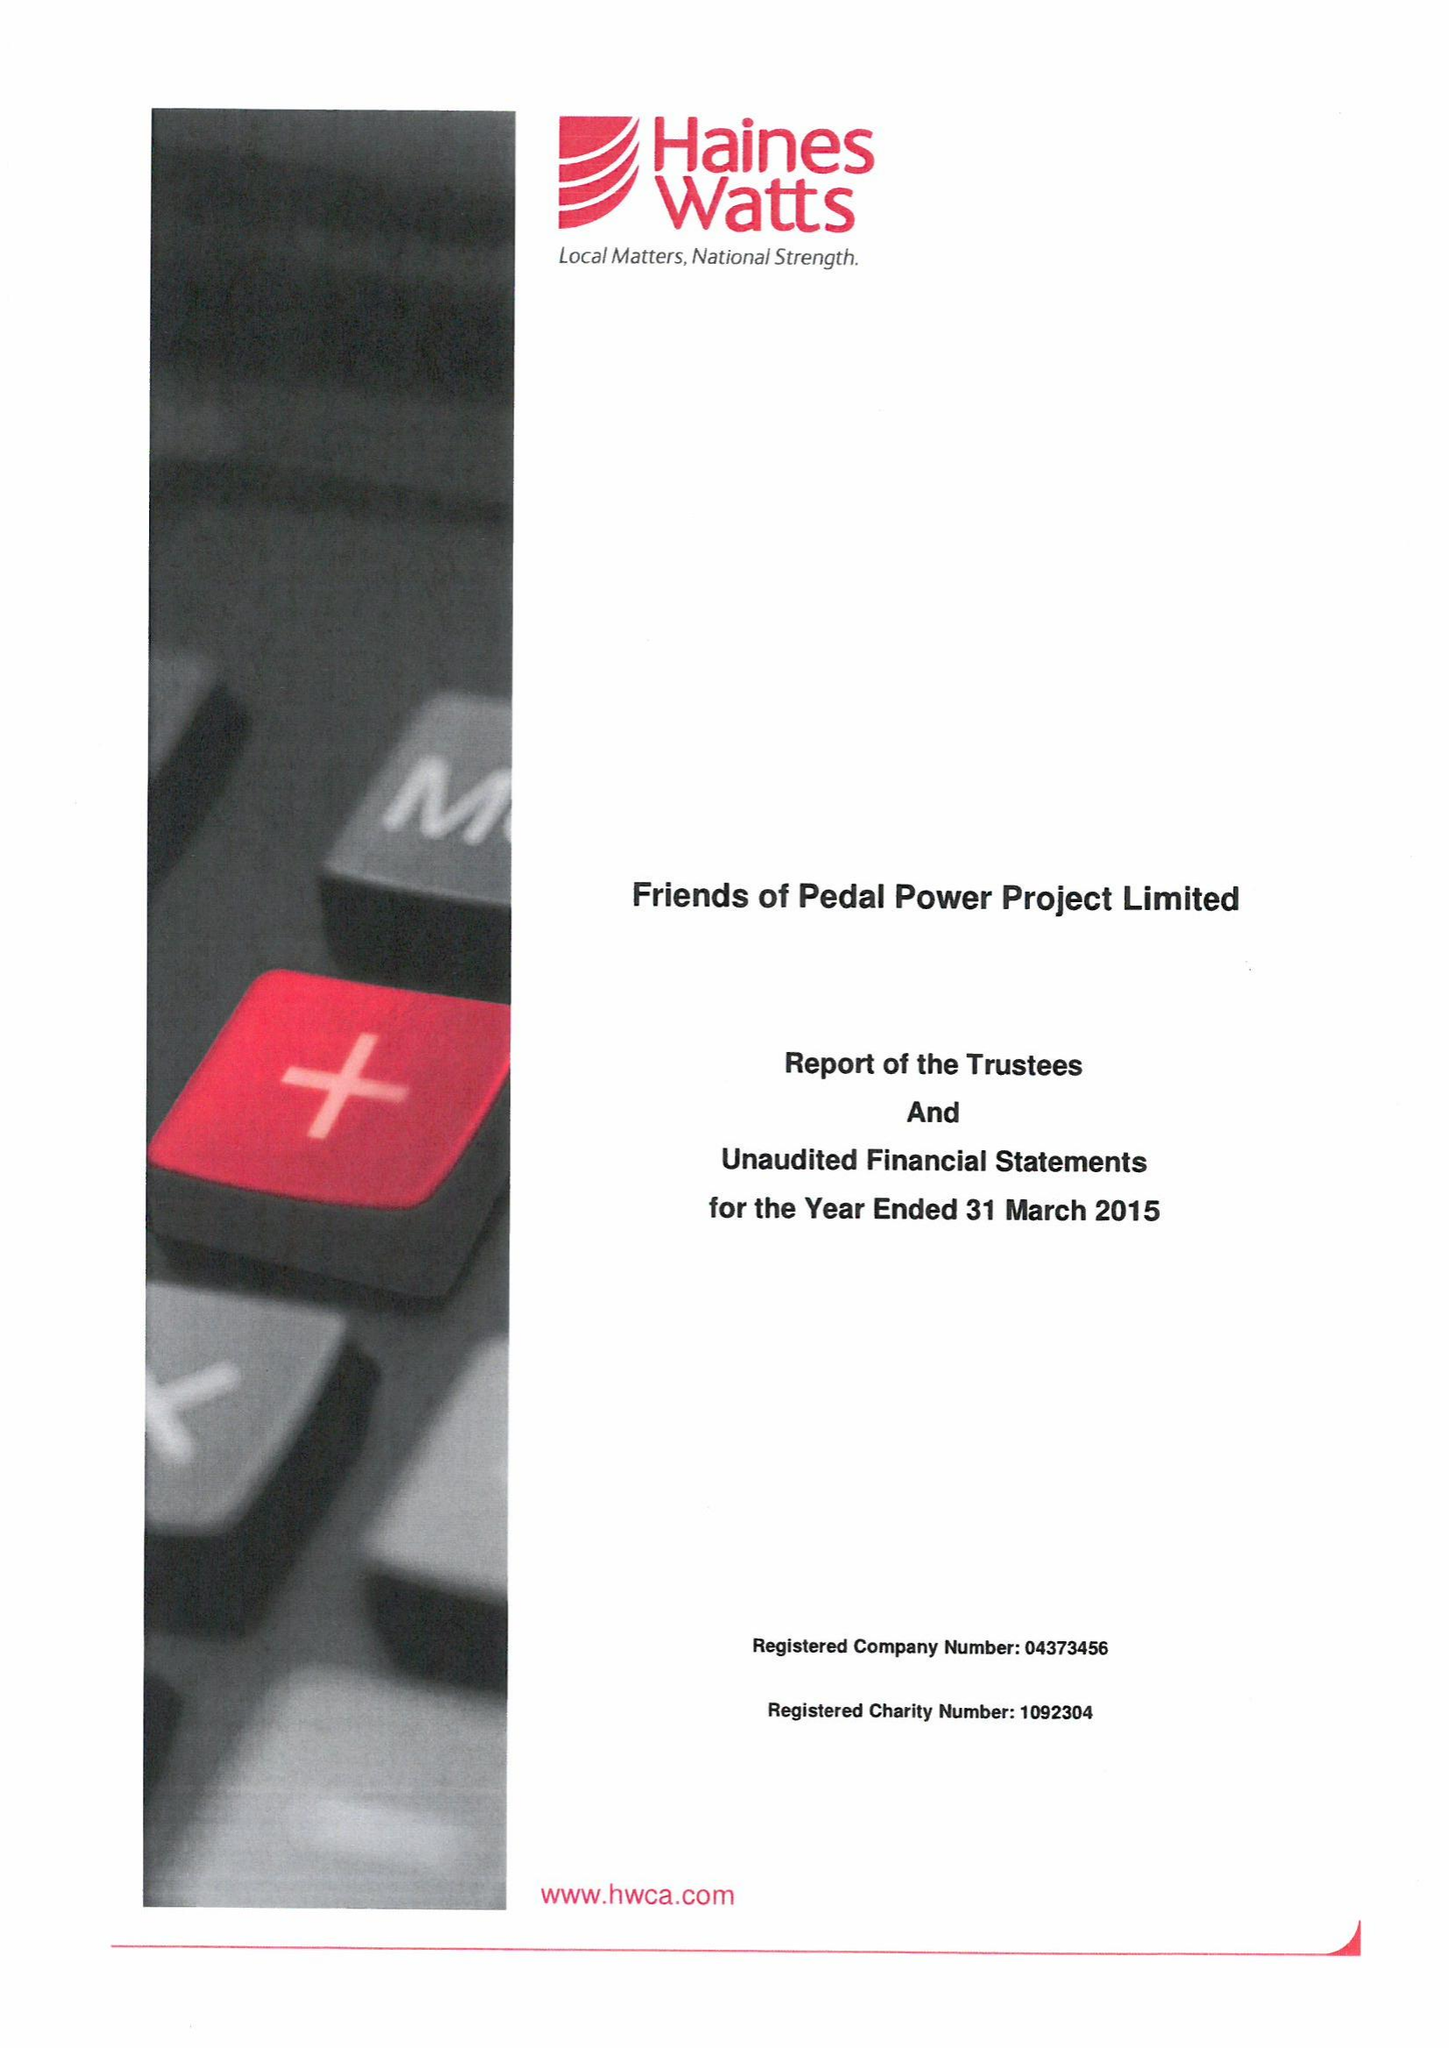What is the value for the report_date?
Answer the question using a single word or phrase. 2015-03-31 